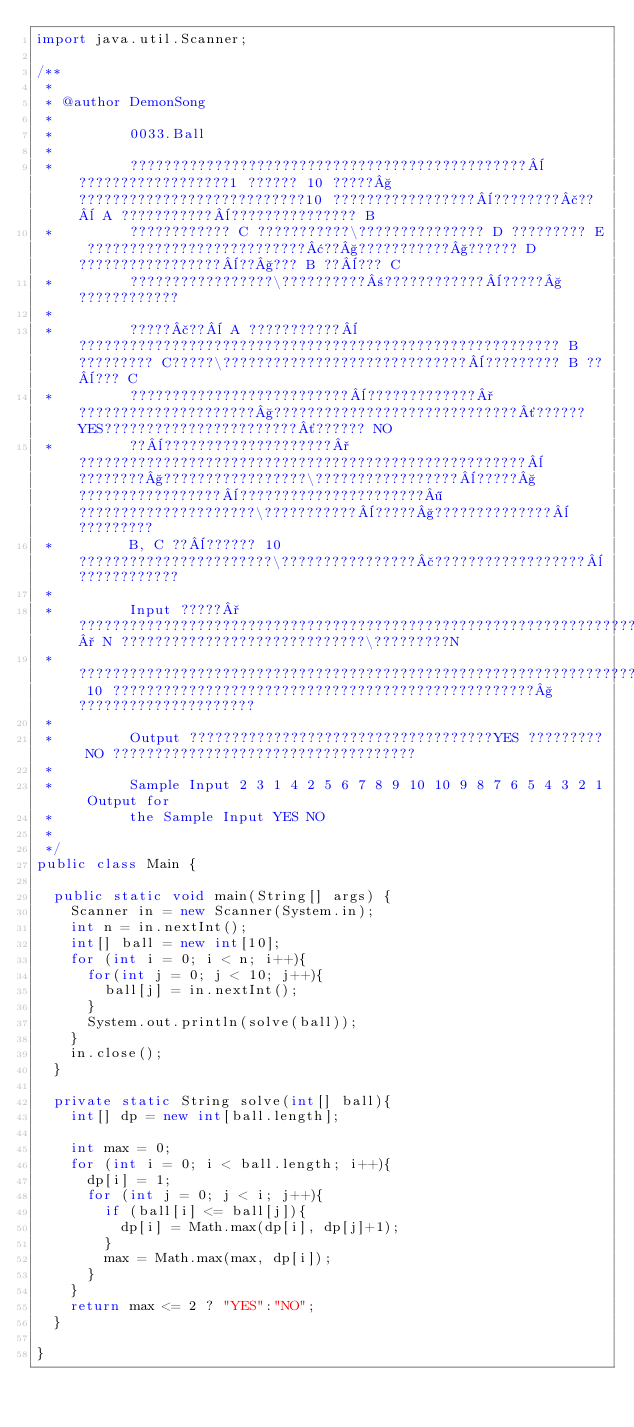<code> <loc_0><loc_0><loc_500><loc_500><_Java_>import java.util.Scanner;

/**
 * 
 * @author DemonSong
 * 
 *         0033.Ball
 * 
 *         ???????????????????????????????????????????????¨??????????????????1 ?????? 10 ?????§???????????????????????????10 ?????????????????¨????????£??¨ A ???????????¨??????????????? B
 *         ???????????? C ???????????\??????????????? D ????????? E ??????????????????????????¢??§???????????§?????? D ?????????????????¨??§??? B ??¨??? C
 *         ?????????????????\??????????±????????????¨?????§????????????
 * 
 *         ?????£??¨ A ???????????¨????????????????????????????????????????????????????????? B ????????? C?????\?????????????????????????????¨????????? B ??¨??? C
 *         ??????????????????????????¨?????????????°?????????????????????§?????????????????????????????´?????? YES???????????????????????´?????? NO
 *         ??¨????????????????????°?????????????????????????????????????????????????????¨????????§?????????????????\?????????????????¨?????§?????????????????¨??????????????????????¶?????????????????????\???????????¨?????§??????????????¨?????????
 *         B, C ??¨?????? 10 ???????????????????????\????????????????£??????????????????¨????????????
 * 
 *         Input ?????°?????????????????????????????????????????????????????????????????????????????° N ?????????????????????????????\?????????N
 *         ???????????????????????????????????????????????????????????????????????? 10 ??????????????????????????????????????????????????§?????????????????????
 * 
 *         Output ????????????????????????????????????YES ????????? NO ????????????????????????????????????
 * 
 *         Sample Input 2 3 1 4 2 5 6 7 8 9 10 10 9 8 7 6 5 4 3 2 1 Output for
 *         the Sample Input YES NO
 *
 */
public class Main {
	
	public static void main(String[] args) {
		Scanner in = new Scanner(System.in);
		int n = in.nextInt();
		int[] ball = new int[10];
		for (int i = 0; i < n; i++){
			for(int j = 0; j < 10; j++){
				ball[j] = in.nextInt();
			}
			System.out.println(solve(ball));
		}
		in.close();
	}
	
	private static String solve(int[] ball){
		int[] dp = new int[ball.length];
		
		int max = 0;
		for (int i = 0; i < ball.length; i++){
			dp[i] = 1;
			for (int j = 0; j < i; j++){
				if (ball[i] <= ball[j]){
					dp[i] = Math.max(dp[i], dp[j]+1);
				}
				max = Math.max(max, dp[i]);
			}
		}
		return max <= 2 ? "YES":"NO";
	}

}</code> 